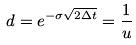Convert formula to latex. <formula><loc_0><loc_0><loc_500><loc_500>d = e ^ { - \sigma \sqrt { 2 \Delta t } } = \frac { 1 } { u }</formula> 